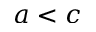Convert formula to latex. <formula><loc_0><loc_0><loc_500><loc_500>a < c</formula> 